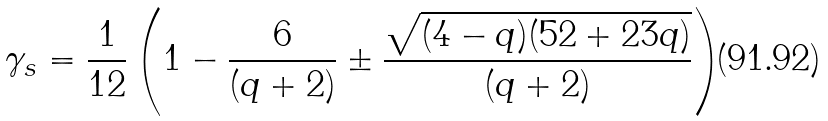<formula> <loc_0><loc_0><loc_500><loc_500>\gamma _ { s } = \frac { 1 } { 1 2 } \left ( 1 - \frac { 6 } { ( q + 2 ) } \pm \frac { \sqrt { ( 4 - q ) ( 5 2 + 2 3 q ) } } { ( q + 2 ) } \right )</formula> 